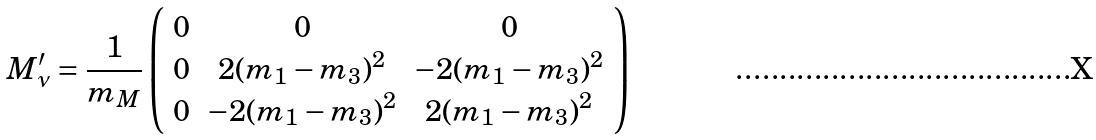<formula> <loc_0><loc_0><loc_500><loc_500>M _ { \nu } ^ { \prime } = \frac { 1 } { m _ { M } } \left ( \begin{array} { c c c } 0 & 0 & 0 \\ 0 & 2 ( m _ { 1 } - m _ { 3 } ) ^ { 2 } & - 2 ( m _ { 1 } - m _ { 3 } ) ^ { 2 } \\ 0 & - 2 ( m _ { 1 } - m _ { 3 } ) ^ { 2 } & 2 ( m _ { 1 } - m _ { 3 } ) ^ { 2 } \end{array} \right )</formula> 